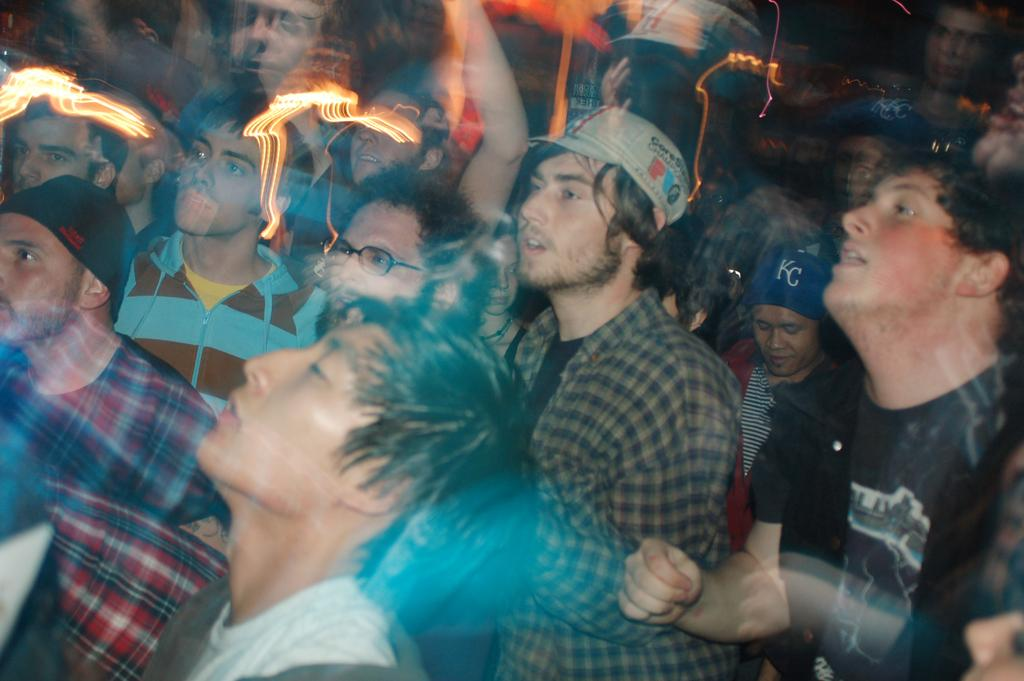What can be seen in the image? There is a group of people in the image. Where are the lights located in the image? The lights are in the left corner of the image. What type of zephyr can be seen blowing through the image? There is no zephyr present in the image; it is a group of people and lights. 